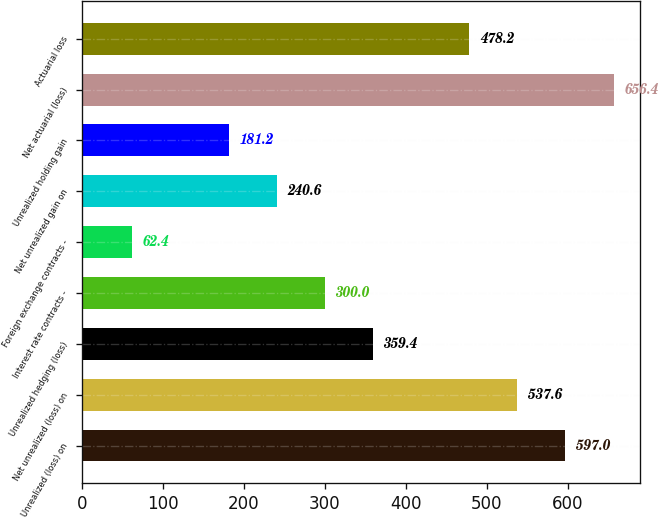Convert chart. <chart><loc_0><loc_0><loc_500><loc_500><bar_chart><fcel>Unrealized (loss) on<fcel>Net unrealized (loss) on<fcel>Unrealized hedging (loss)<fcel>Interest rate contracts -<fcel>Foreign exchange contracts -<fcel>Net unrealized gain on<fcel>Unrealized holding gain<fcel>Net actuarial (loss)<fcel>Actuarial loss<nl><fcel>597<fcel>537.6<fcel>359.4<fcel>300<fcel>62.4<fcel>240.6<fcel>181.2<fcel>656.4<fcel>478.2<nl></chart> 